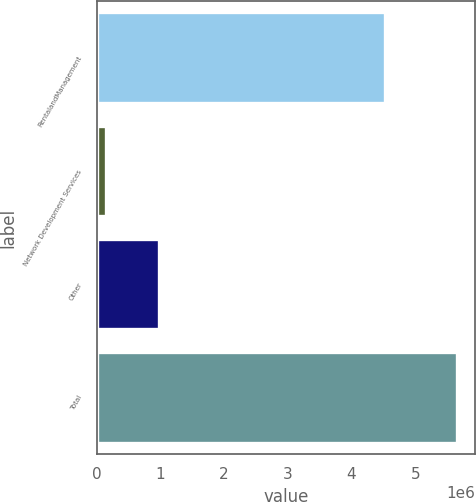Convert chart to OTSL. <chart><loc_0><loc_0><loc_500><loc_500><bar_chart><fcel>RentalandManagement<fcel>Network Development Services<fcel>Other<fcel>Total<nl><fcel>4.52841e+06<fcel>147045<fcel>986747<fcel>5.6622e+06<nl></chart> 